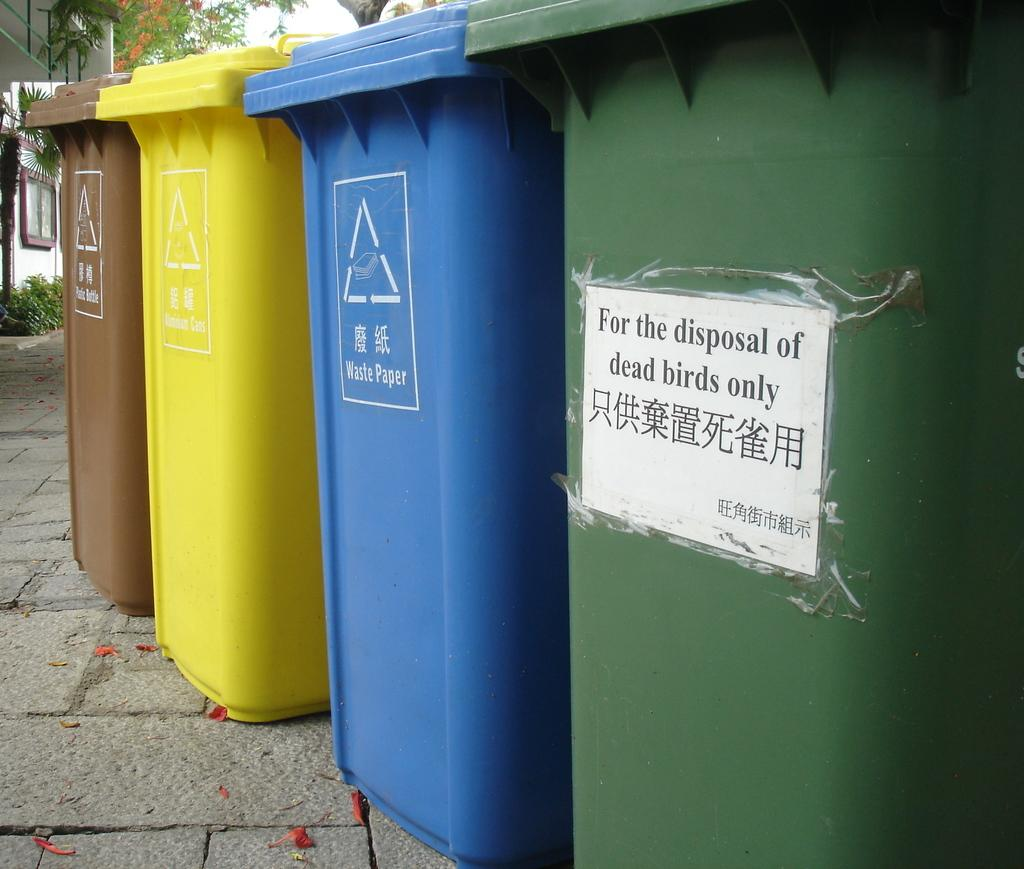<image>
Provide a brief description of the given image. Four trash cans are lined up together and one is marked for dead birds only. 